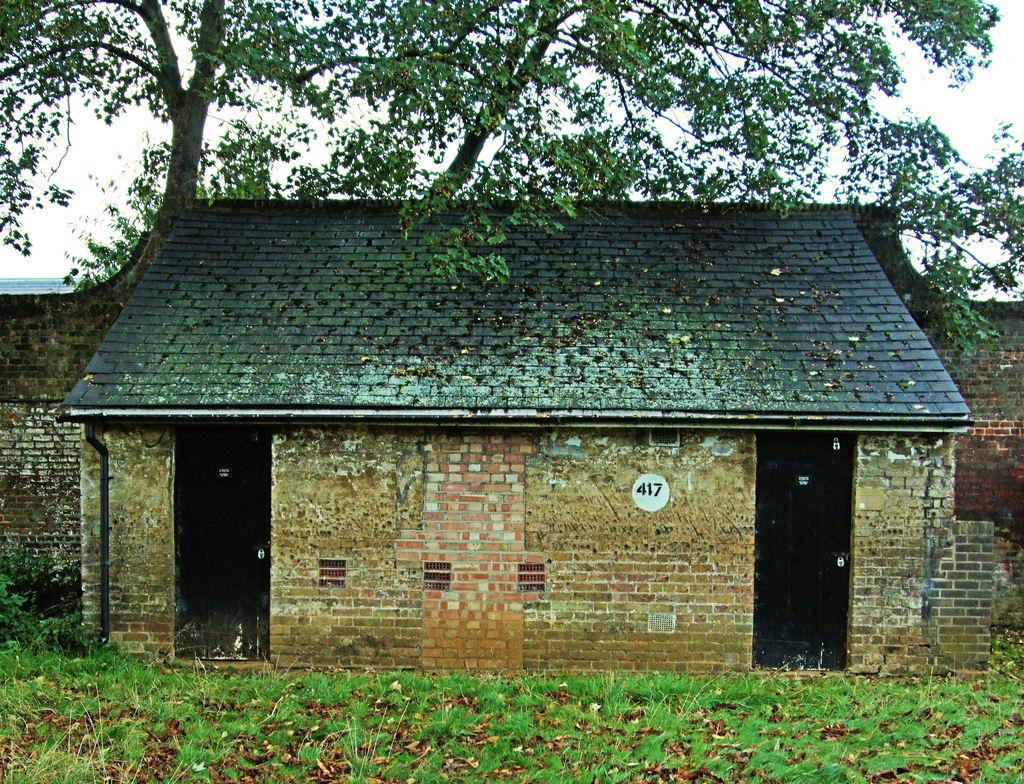What is the main subject in the center of the image? There is a house in the center of the image. What can be used to enter or exit the house in the image? There are doors in the image. What is visible in the background of the image? There is a wall and trees in the background of the image. What type of vegetation is present at the bottom of the image? There are plants and grass at the bottom of the image. Can you tell me how many goats are standing next to the wall in the image? There are no goats present in the image; it only features a house, doors, a wall, trees, plants, and grass. 